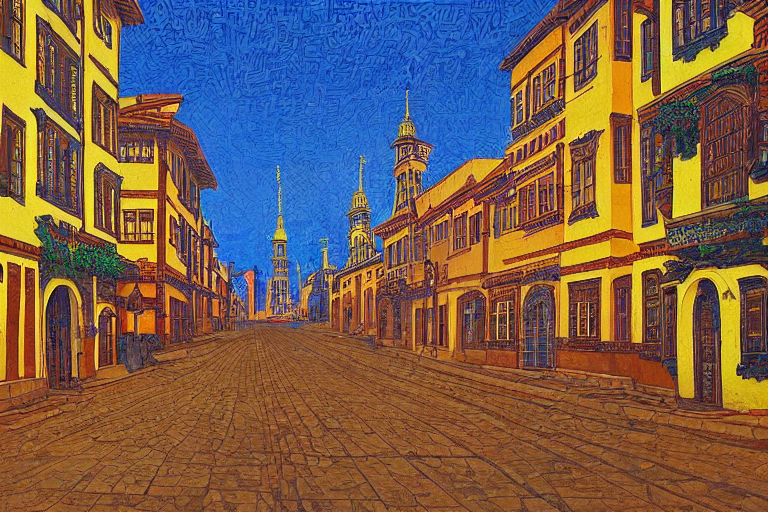Is the image professionally executed? While the original answer was 'A. No', implying that the image is not professionally executed, this assessment seems to undervalue the image's artistic qualities. The picture does indeed seem to be the product of a professional or at least a skilled hand, employing a creative technique reminiscent of post-impressionist paintings, where vibrant colors and exaggerated forms create a stylized depiction of a streetscape. The result is visually striking and demonstrates both technical proficiency and a distinct artistic style. 